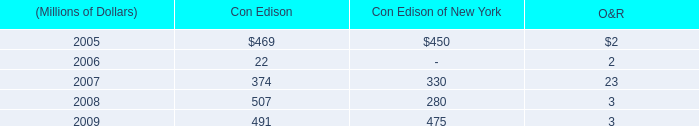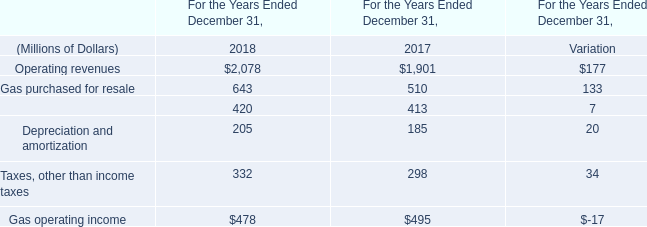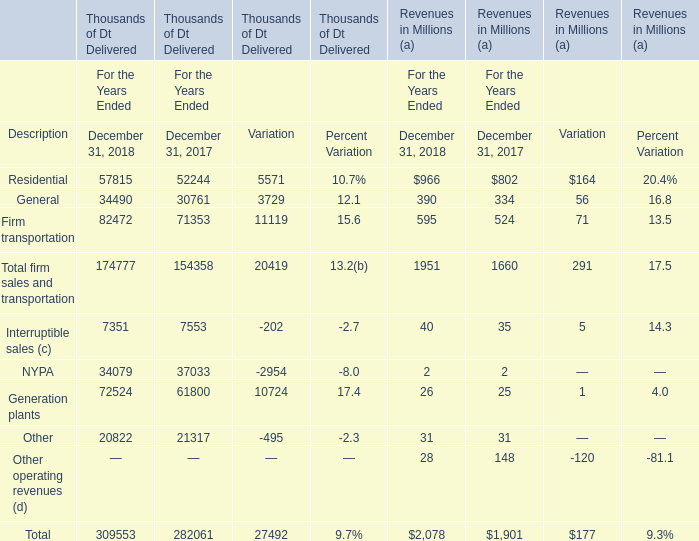What will Residential Revenues be like in 2019 if it develops with the same increasing rate as current? (in million) 
Computations: (966 + ((966 * (966 - 802)) / 802))
Answer: 1163.53616. 